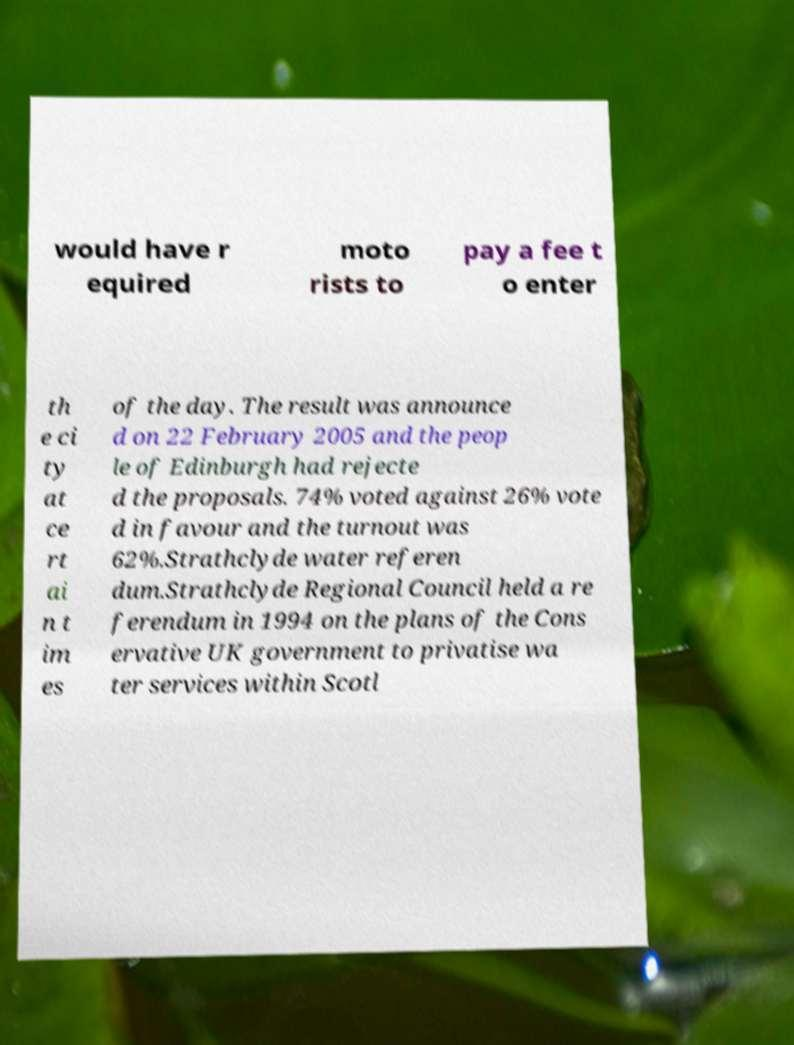Could you extract and type out the text from this image? would have r equired moto rists to pay a fee t o enter th e ci ty at ce rt ai n t im es of the day. The result was announce d on 22 February 2005 and the peop le of Edinburgh had rejecte d the proposals. 74% voted against 26% vote d in favour and the turnout was 62%.Strathclyde water referen dum.Strathclyde Regional Council held a re ferendum in 1994 on the plans of the Cons ervative UK government to privatise wa ter services within Scotl 